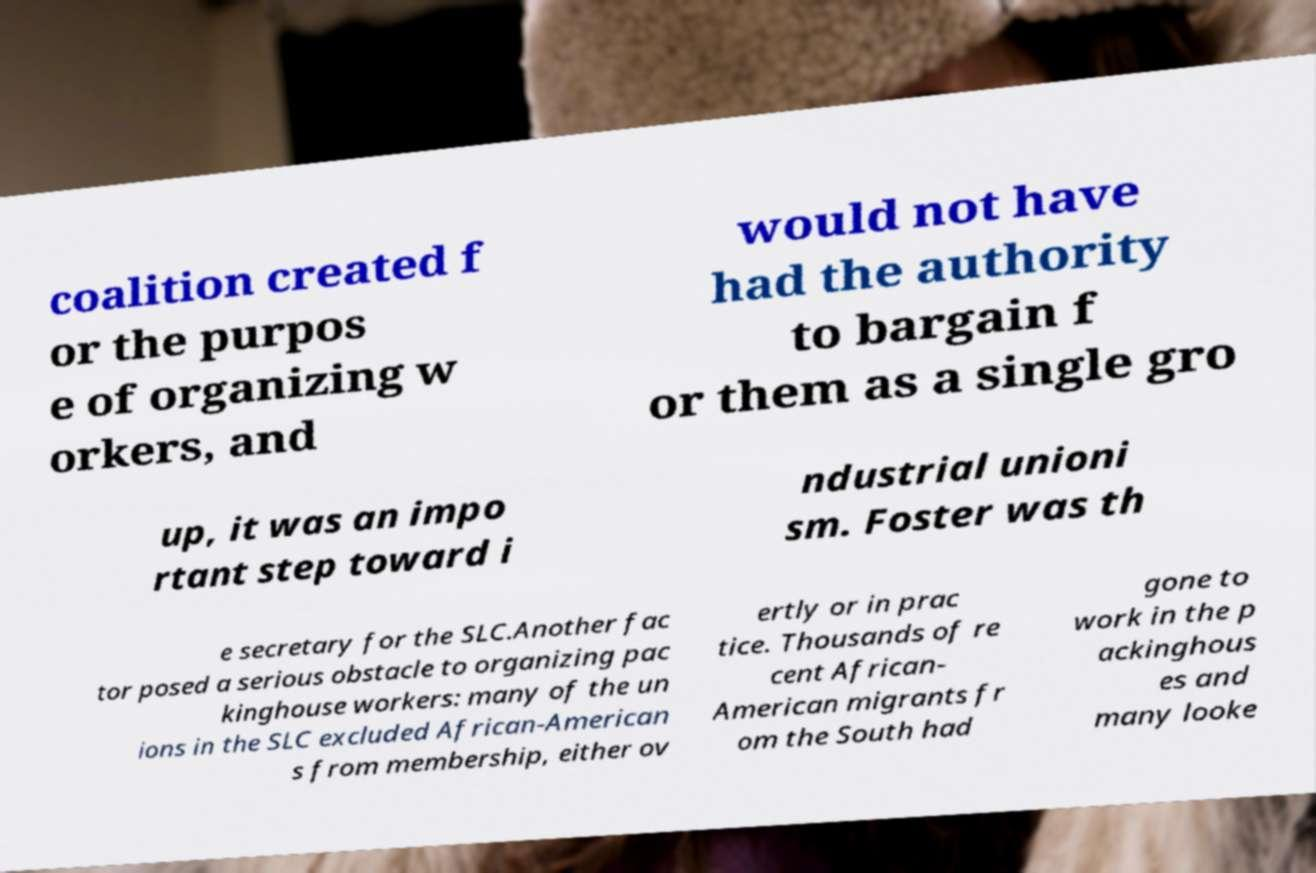Can you accurately transcribe the text from the provided image for me? coalition created f or the purpos e of organizing w orkers, and would not have had the authority to bargain f or them as a single gro up, it was an impo rtant step toward i ndustrial unioni sm. Foster was th e secretary for the SLC.Another fac tor posed a serious obstacle to organizing pac kinghouse workers: many of the un ions in the SLC excluded African-American s from membership, either ov ertly or in prac tice. Thousands of re cent African- American migrants fr om the South had gone to work in the p ackinghous es and many looke 